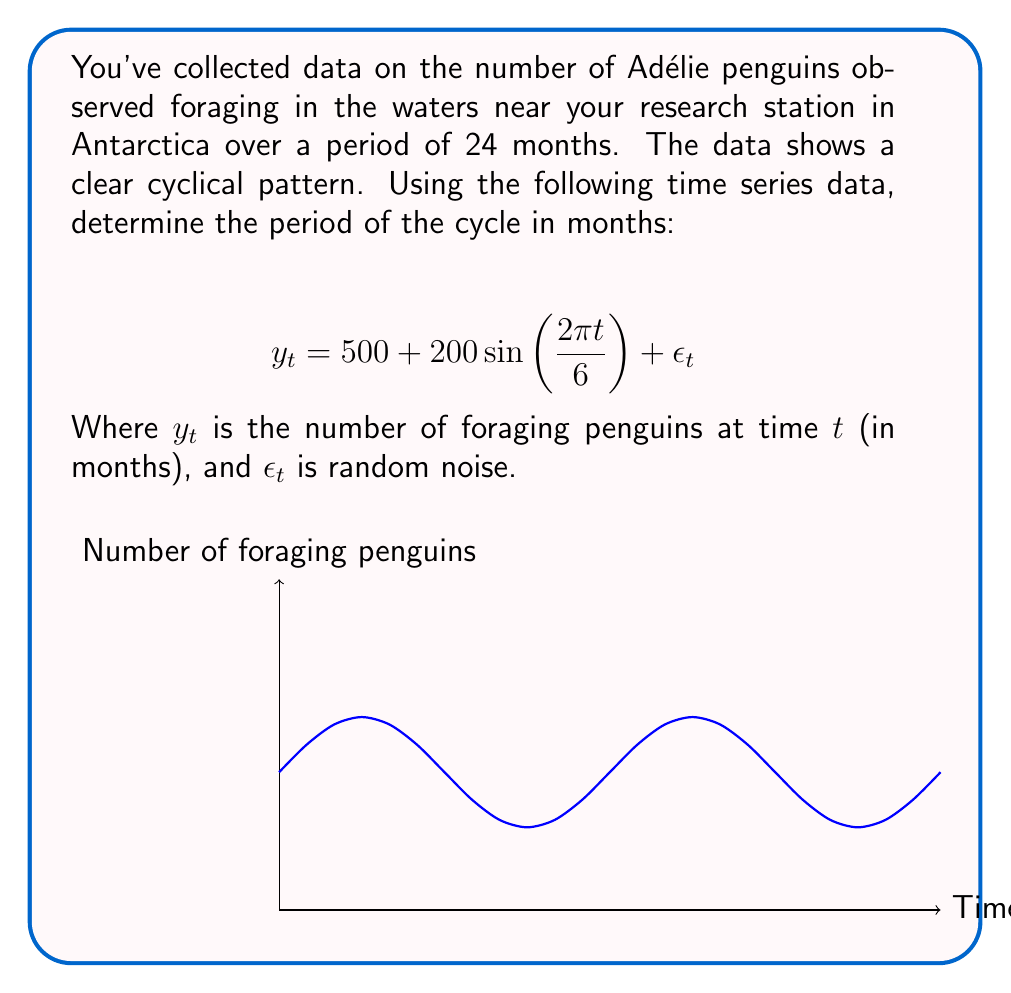Show me your answer to this math problem. To determine the period of the cycle, we need to analyze the sinusoidal component of the time series equation:

1) The general form of a sine wave is:
   $$A\sin(\omega t + \phi)$$
   where $A$ is the amplitude, $\omega$ is the angular frequency, and $\phi$ is the phase shift.

2) In our equation, we have:
   $$200\sin(\frac{2\pi t}{6})$$

3) Comparing this to the general form, we can see that:
   $$\omega = \frac{2\pi}{6}$$

4) The period $T$ of a sine wave is related to the angular frequency $\omega$ by:
   $$T = \frac{2\pi}{\omega}$$

5) Substituting our $\omega$:
   $$T = \frac{2\pi}{\frac{2\pi}{6}} = 6$$

Therefore, the period of the cycle is 6 months.

This means that the foraging behavior of the Adélie penguins repeats every 6 months, which could be related to seasonal changes in the Antarctic environment affecting food availability or breeding cycles.
Answer: 6 months 